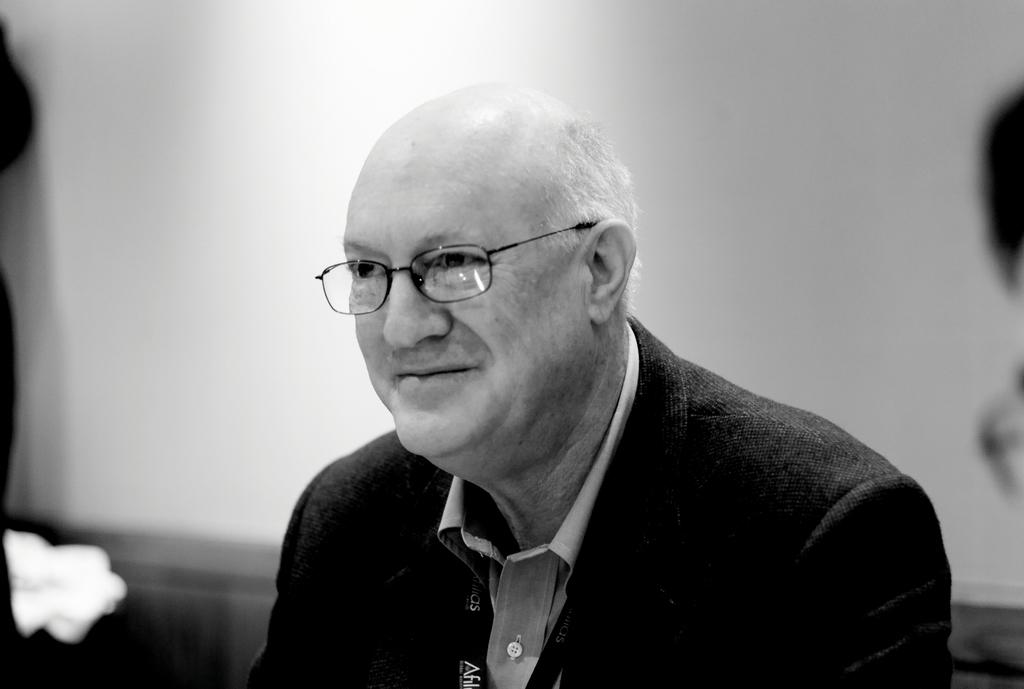What is the color scheme of the image? The image is black and white. What subject is depicted in the image? The image depicts an old person. Can you describe the background of the image? The background of the image is blurred. Where is the cup placed in the image? There is no cup present in the image. What type of pin is the old person wearing in the image? There is no pin visible in the image. 